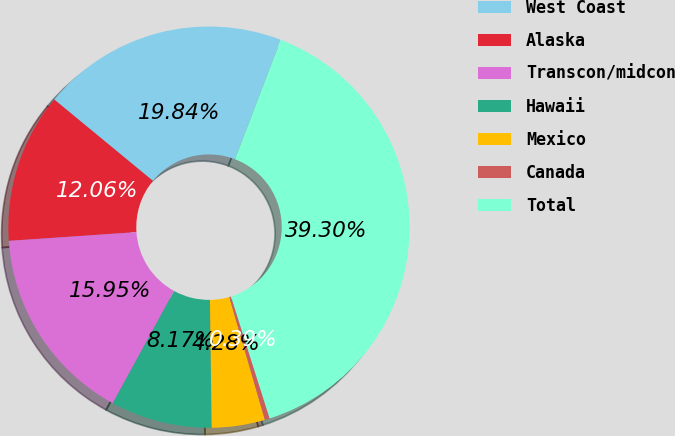<chart> <loc_0><loc_0><loc_500><loc_500><pie_chart><fcel>West Coast<fcel>Alaska<fcel>Transcon/midcon<fcel>Hawaii<fcel>Mexico<fcel>Canada<fcel>Total<nl><fcel>19.84%<fcel>12.06%<fcel>15.95%<fcel>8.17%<fcel>4.28%<fcel>0.39%<fcel>39.29%<nl></chart> 